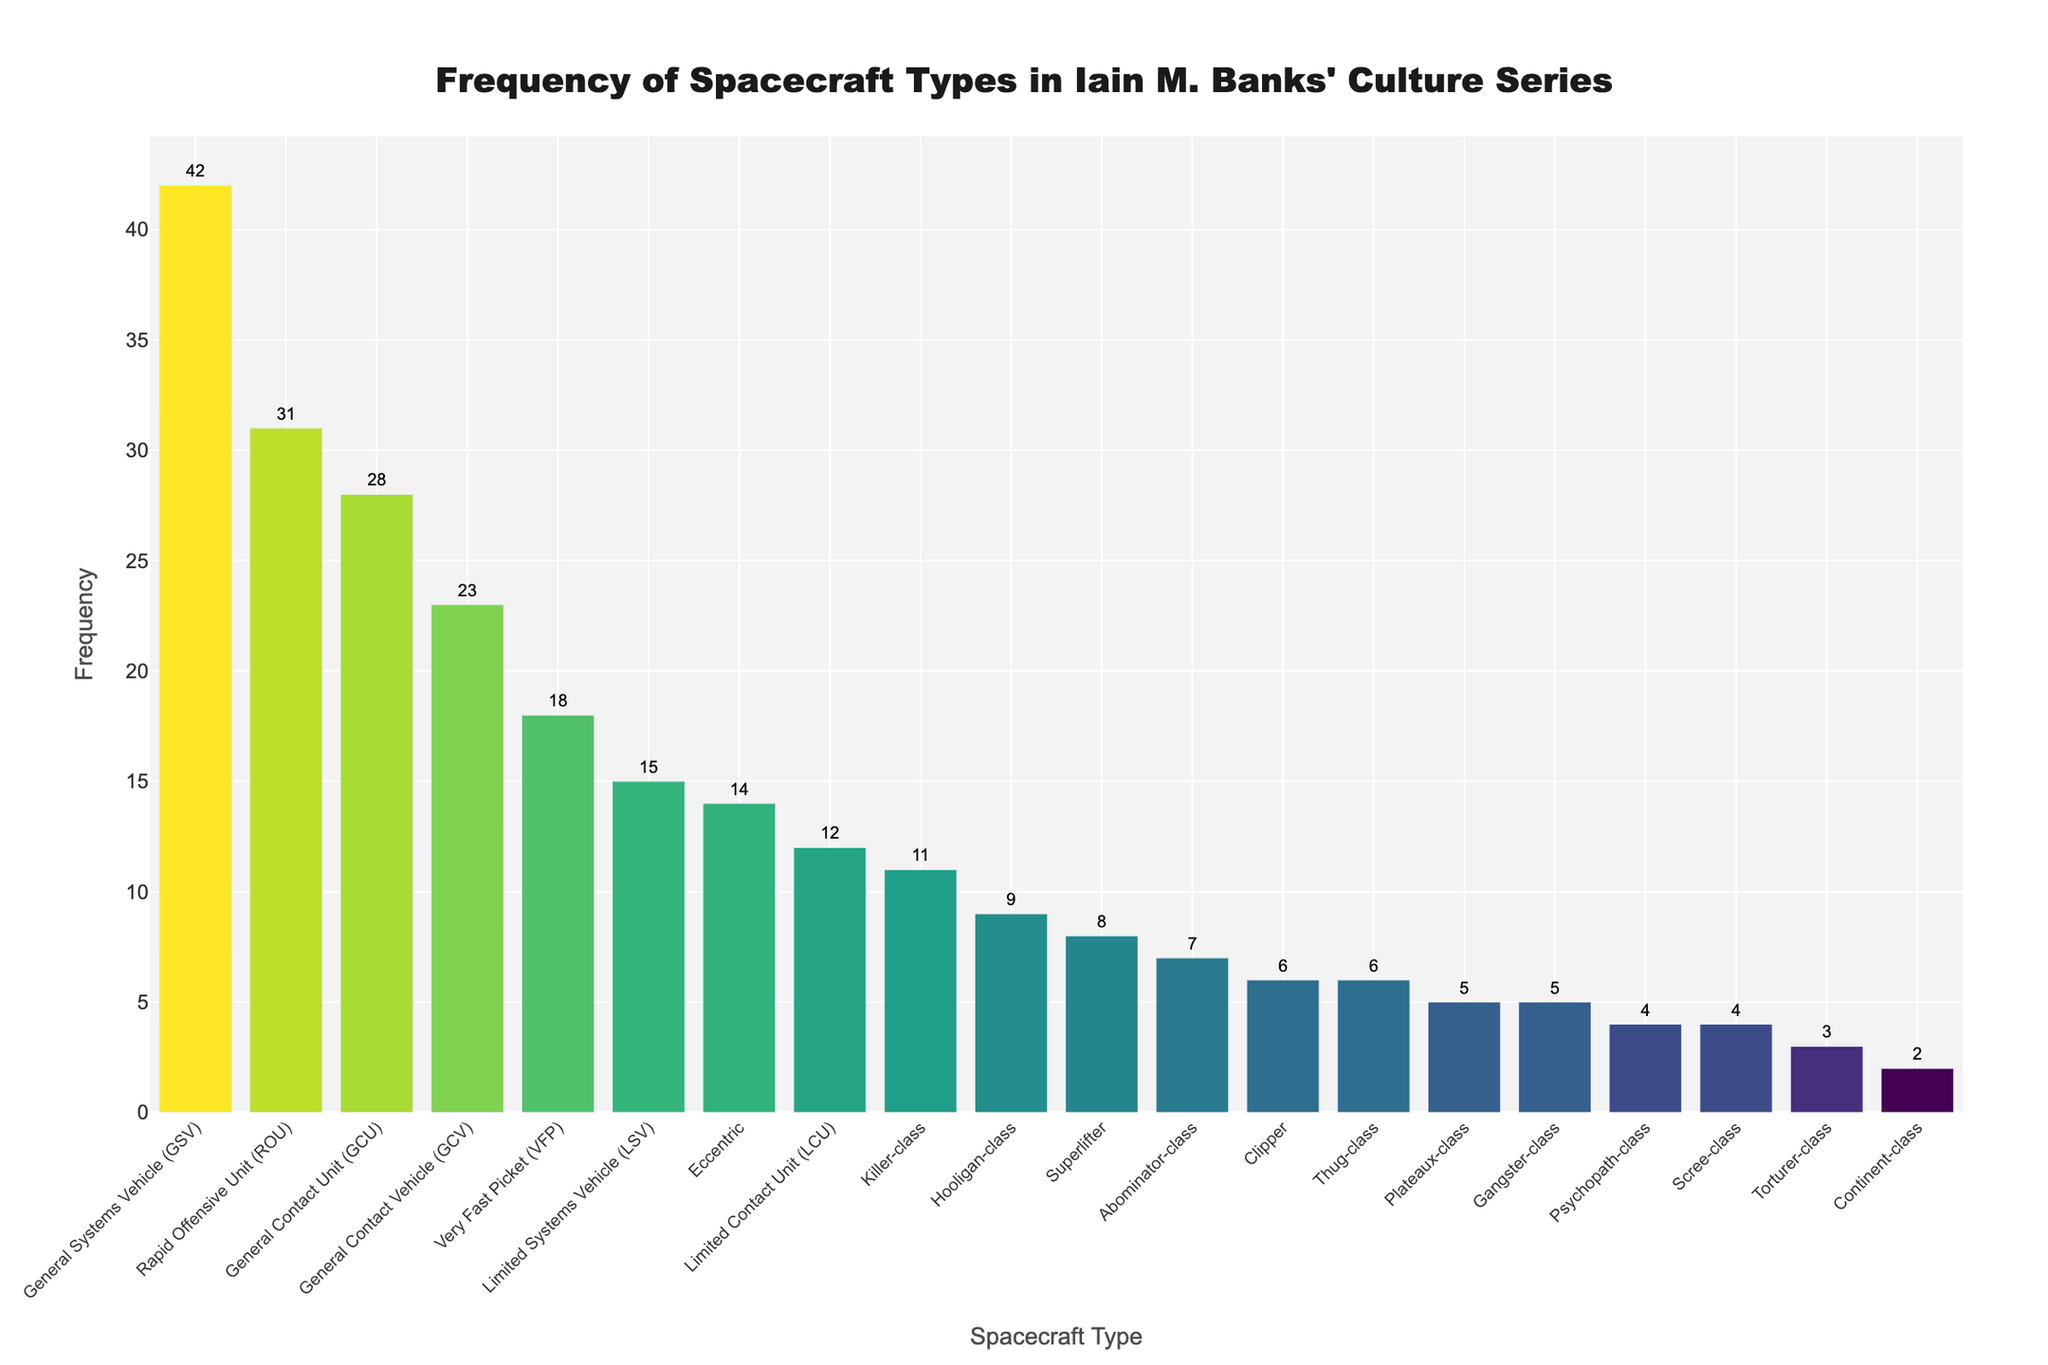Which spacecraft type is mentioned the most in Banks' Culture series? The tallest bar in the chart represents the spacecraft type with the highest frequency. The "General Systems Vehicle (GSV)" has the tallest bar.
Answer: General Systems Vehicle (GSV) Which spacecraft type is mentioned the least in Banks' Culture series? The shortest bar in the chart shows the spacecraft type with the lowest frequency. The "Continent-class" has the shortest bar with a frequency of 2.
Answer: Continent-class How many times more frequent are General Systems Vehicles (GSVs) compared to Limited Systems Vehicles (LSVs)? The frequency of GSVs is 42, and the frequency of LSVs is 15. Divide 42 by 15 to get the ratio.
Answer: 2.8 Which spacecraft type is more mentioned, Gangster-class or Eccentric, and by how much? Compare the heights of the bars for Gangster-class (5) and Eccentric (14). Subtract the frequency of Gangster-class from Eccentric.
Answer: Eccentric by 9 What's the combined frequency of the General Contact Vehicle (GCV) and Rapid Offensive Unit (ROU)? Sum the frequencies of GCV (23) and ROU (31).
Answer: 54 How many spacecraft types have a frequency greater than 20? Count the bars that have heights representing frequencies greater than 20: GSV, GCV, ROU, GCU. There are four such types.
Answer: 4 What is the median frequency of all spacecraft types? Order the frequencies and find the middle value. The sorted frequencies are: 2, 3, 4, 4, 5, 5, 6, 6, 7, 8, 9, 11, 12, 14, 15, 18, 23, 28, 31, 42. The median is the average of the 10th and 11th values (8 and 9).
Answer: 8.5 Which spacecraft types have a frequency between 5 and 15? Identify the bars with frequencies falling within the specified range: Killer-class, Thug-class, Abominator-class, Hooligan-class, Plateaux-class, Gangster-class, Eccentric, LCU, LSV, and VFP.
Answer: 10 